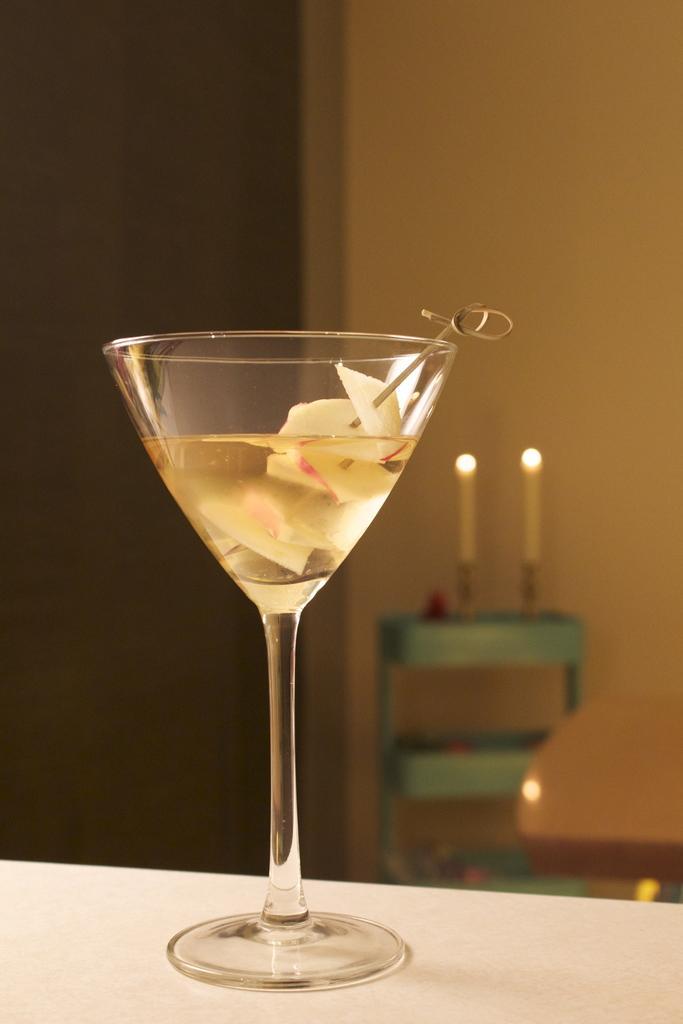Can you describe this image briefly? In the foreground of this image, there is a glass with liquid on a table. In the background, there are candles on a stand near a wall. 